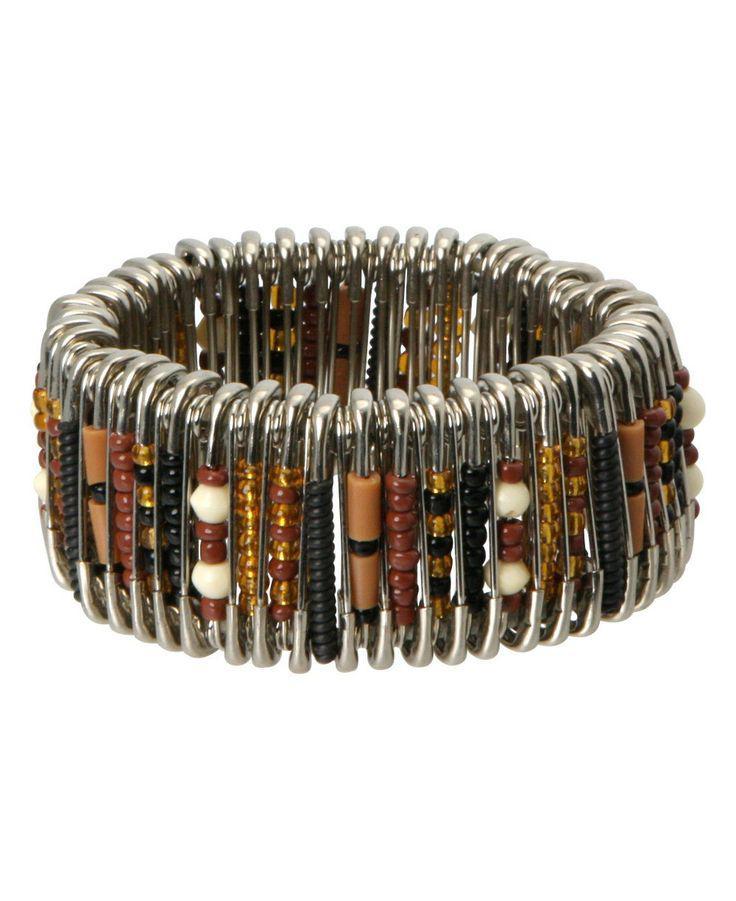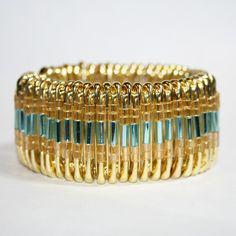The first image is the image on the left, the second image is the image on the right. For the images shown, is this caption "Each image contains one bracelet constructed of rows of vertical beaded safety pins, and no bracelet has a watch face." true? Answer yes or no. Yes. The first image is the image on the left, the second image is the image on the right. Examine the images to the left and right. Is the description "In the left image, all beads are tans, blacks, whites and oranges." accurate? Answer yes or no. Yes. 